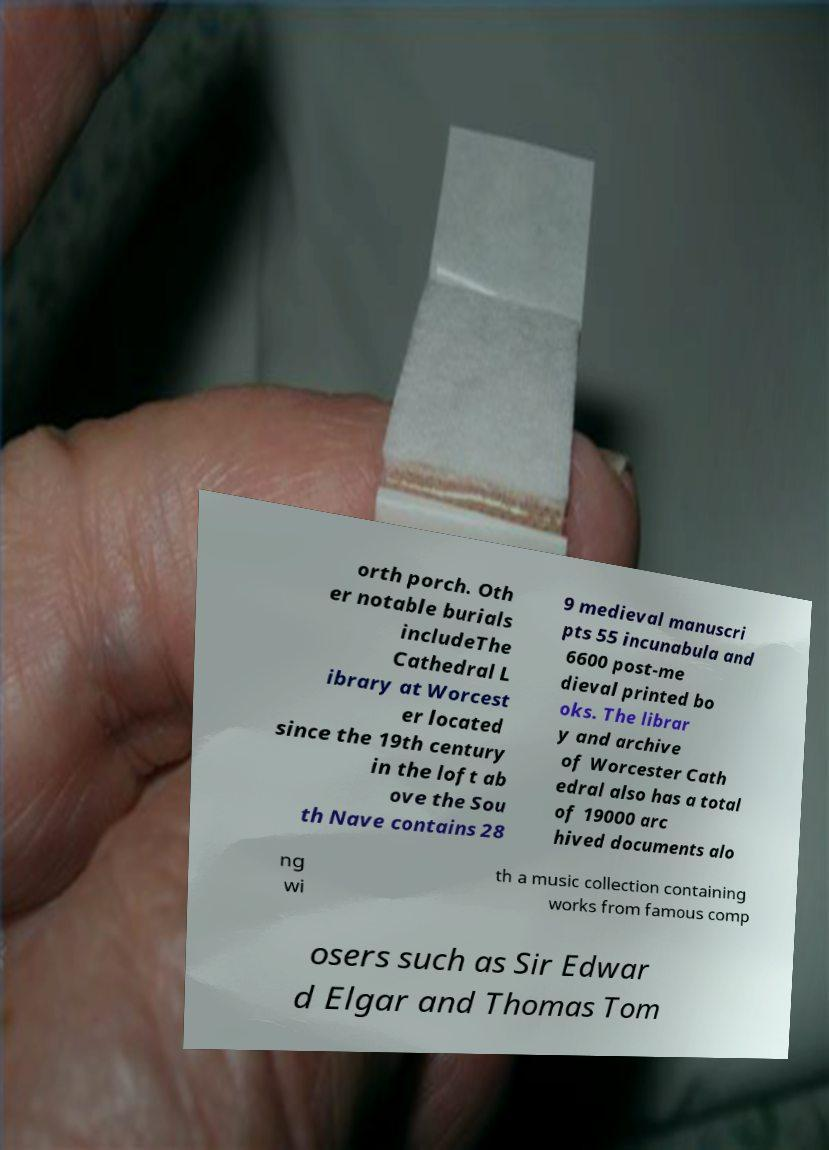Could you extract and type out the text from this image? orth porch. Oth er notable burials includeThe Cathedral L ibrary at Worcest er located since the 19th century in the loft ab ove the Sou th Nave contains 28 9 medieval manuscri pts 55 incunabula and 6600 post-me dieval printed bo oks. The librar y and archive of Worcester Cath edral also has a total of 19000 arc hived documents alo ng wi th a music collection containing works from famous comp osers such as Sir Edwar d Elgar and Thomas Tom 